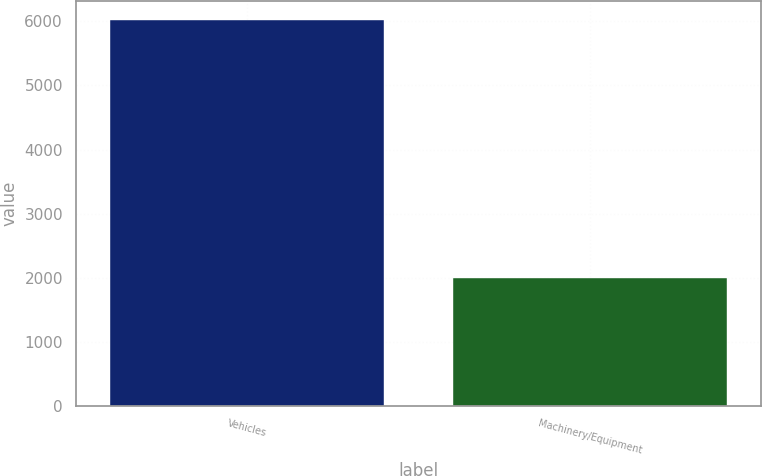Convert chart to OTSL. <chart><loc_0><loc_0><loc_500><loc_500><bar_chart><fcel>Vehicles<fcel>Machinery/Equipment<nl><fcel>6021<fcel>1994<nl></chart> 